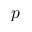Convert formula to latex. <formula><loc_0><loc_0><loc_500><loc_500>p</formula> 